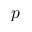Convert formula to latex. <formula><loc_0><loc_0><loc_500><loc_500>p</formula> 